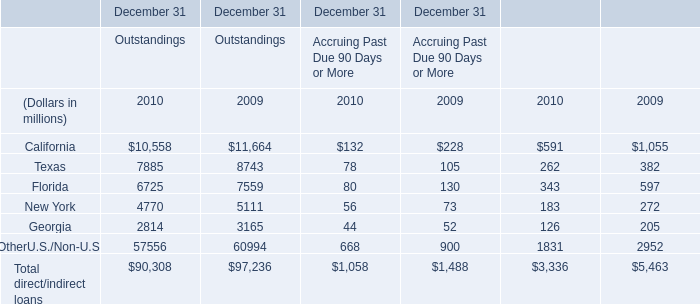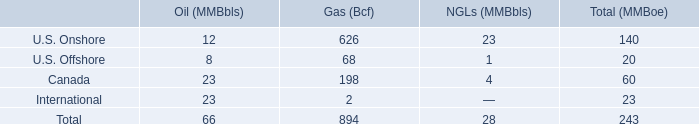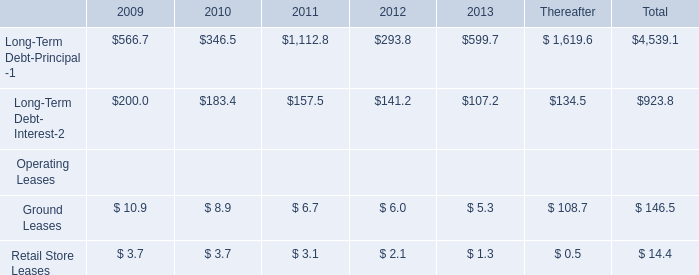What's the sum of direct/indirect loans of Outstandings in 2010? (in dollars in millions) 
Answer: 90308. 